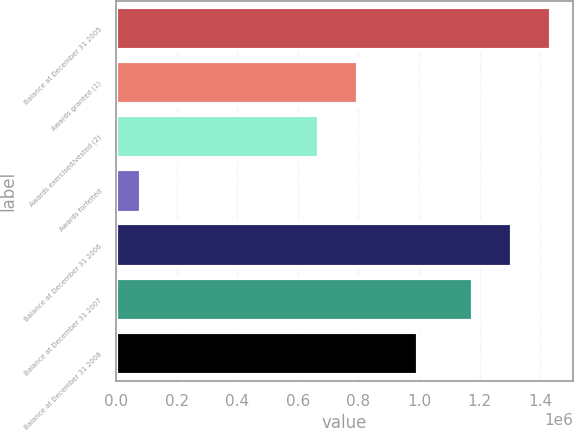<chart> <loc_0><loc_0><loc_500><loc_500><bar_chart><fcel>Balance at December 31 2005<fcel>Awards granted (1)<fcel>Awards exercised/vested (2)<fcel>Awards forfeited<fcel>Balance at December 31 2006<fcel>Balance at December 31 2007<fcel>Balance at December 31 2008<nl><fcel>1.43589e+06<fcel>799621<fcel>670768<fcel>81301<fcel>1.30704e+06<fcel>1.17819e+06<fcel>996011<nl></chart> 